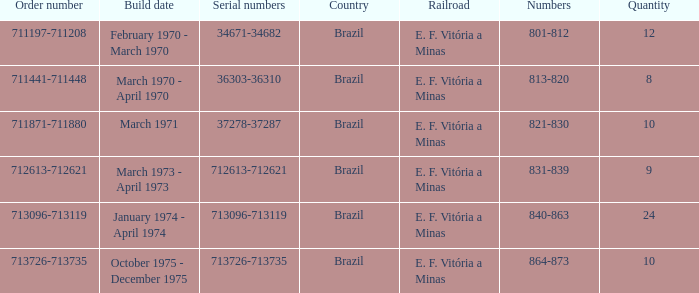The serial numbers 713096-713119 are in which country? Brazil. 